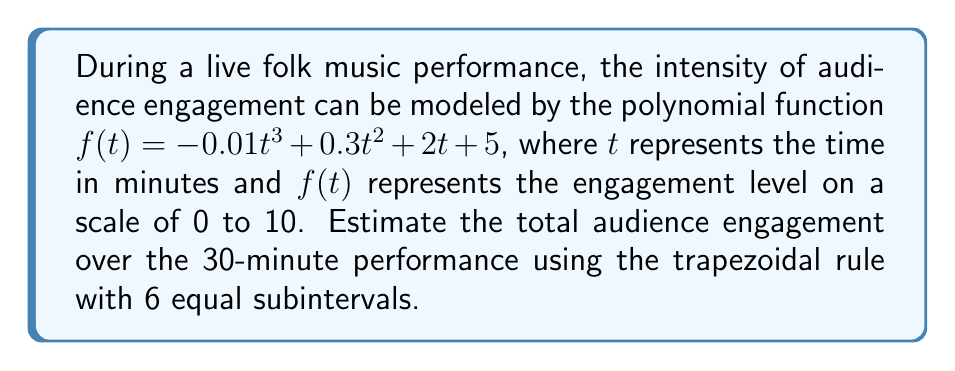Show me your answer to this math problem. To estimate the area under the curve using the trapezoidal rule:

1) Divide the interval [0, 30] into 6 equal subintervals:
   $\Delta t = \frac{30 - 0}{6} = 5$ minutes

2) Calculate $f(t)$ at each point:
   $t_0 = 0$:  $f(0) = 5$
   $t_1 = 5$:  $f(5) = -0.01(125) + 0.3(25) + 2(5) + 5 = 21.25$
   $t_2 = 10$: $f(10) = -0.01(1000) + 0.3(100) + 2(10) + 5 = 35$
   $t_3 = 15$: $f(15) = -0.01(3375) + 0.3(225) + 2(15) + 5 = 46.25$
   $t_4 = 20$: $f(20) = -0.01(8000) + 0.3(400) + 2(20) + 5 = 55$
   $t_5 = 25$: $f(25) = -0.01(15625) + 0.3(625) + 2(25) + 5 = 61.25$
   $t_6 = 30$: $f(30) = -0.01(27000) + 0.3(900) + 2(30) + 5 = 65$

3) Apply the trapezoidal rule formula:
   $$A \approx \frac{\Delta t}{2}[f(t_0) + 2f(t_1) + 2f(t_2) + 2f(t_3) + 2f(t_4) + 2f(t_5) + f(t_6)]$$

4) Substitute the values:
   $$A \approx \frac{5}{2}[5 + 2(21.25) + 2(35) + 2(46.25) + 2(55) + 2(61.25) + 65]$$

5) Calculate:
   $$A \approx \frac{5}{2}[5 + 42.5 + 70 + 92.5 + 110 + 122.5 + 65]$$
   $$A \approx \frac{5}{2}(507.5) = 1268.75$$

The estimated total audience engagement over the 30-minute performance is 1268.75 engagement-minutes.
Answer: 1268.75 engagement-minutes 